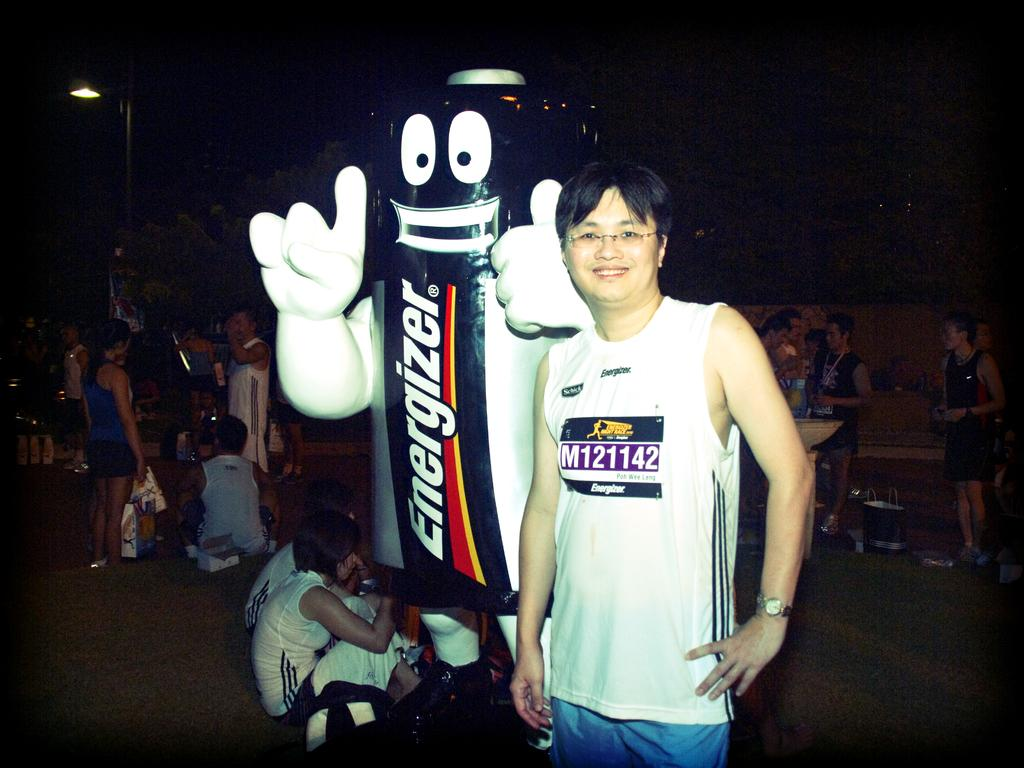Provide a one-sentence caption for the provided image. A man stands next to someone in an Energizer battery costume. 